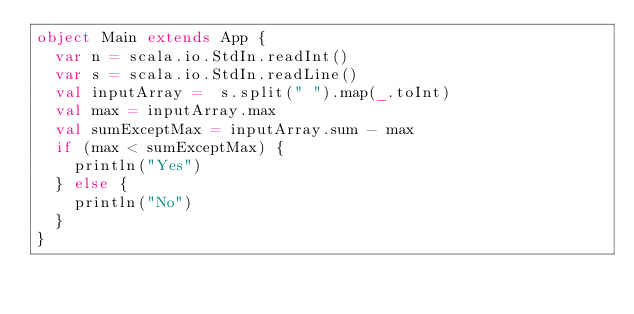Convert code to text. <code><loc_0><loc_0><loc_500><loc_500><_Scala_>object Main extends App {
  var n = scala.io.StdIn.readInt()
  var s = scala.io.StdIn.readLine()
  val inputArray =  s.split(" ").map(_.toInt)
  val max = inputArray.max
  val sumExceptMax = inputArray.sum - max
  if (max < sumExceptMax) {
    println("Yes")
  } else {
    println("No")
  }
}
</code> 